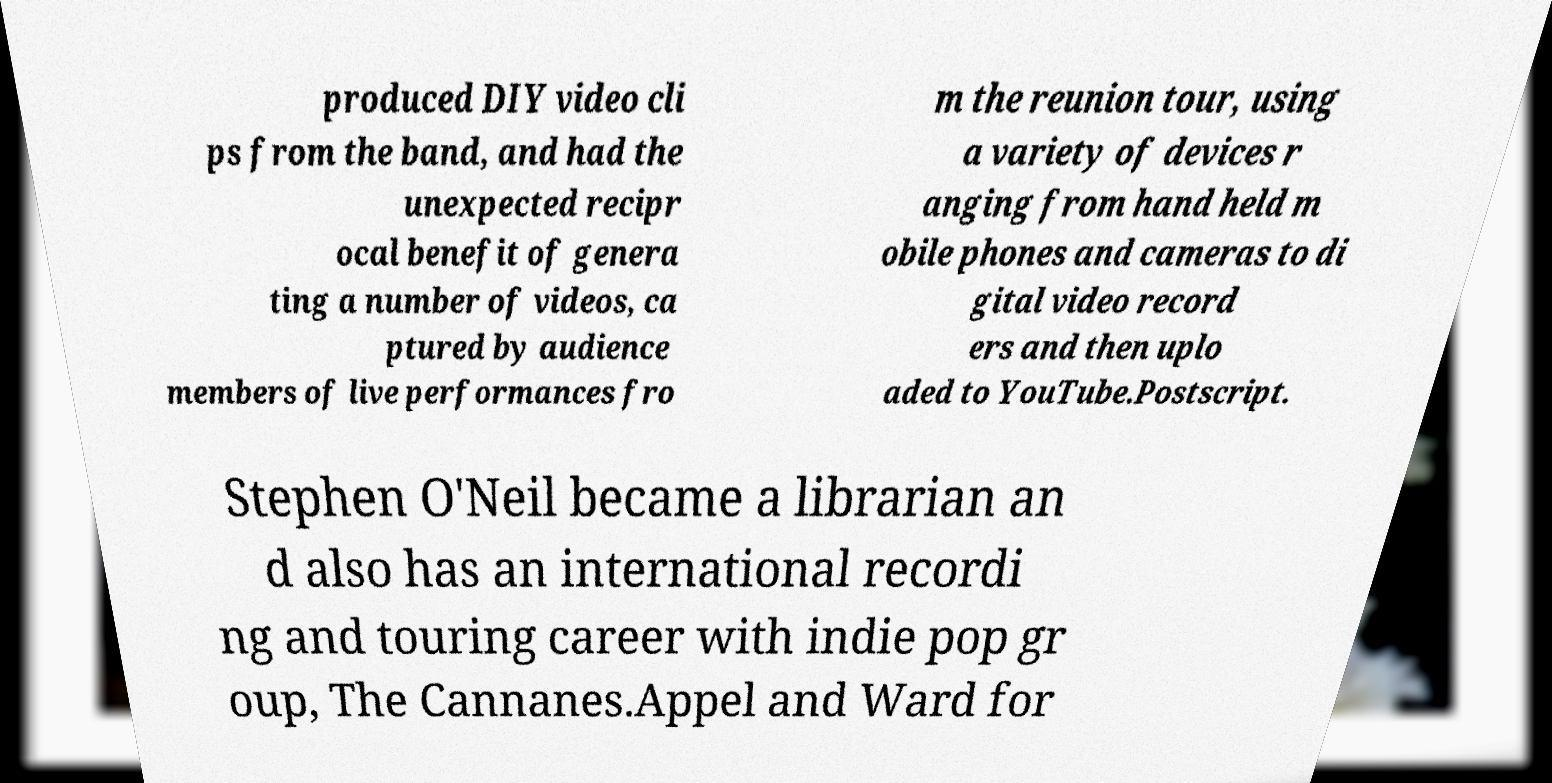Could you assist in decoding the text presented in this image and type it out clearly? produced DIY video cli ps from the band, and had the unexpected recipr ocal benefit of genera ting a number of videos, ca ptured by audience members of live performances fro m the reunion tour, using a variety of devices r anging from hand held m obile phones and cameras to di gital video record ers and then uplo aded to YouTube.Postscript. Stephen O'Neil became a librarian an d also has an international recordi ng and touring career with indie pop gr oup, The Cannanes.Appel and Ward for 